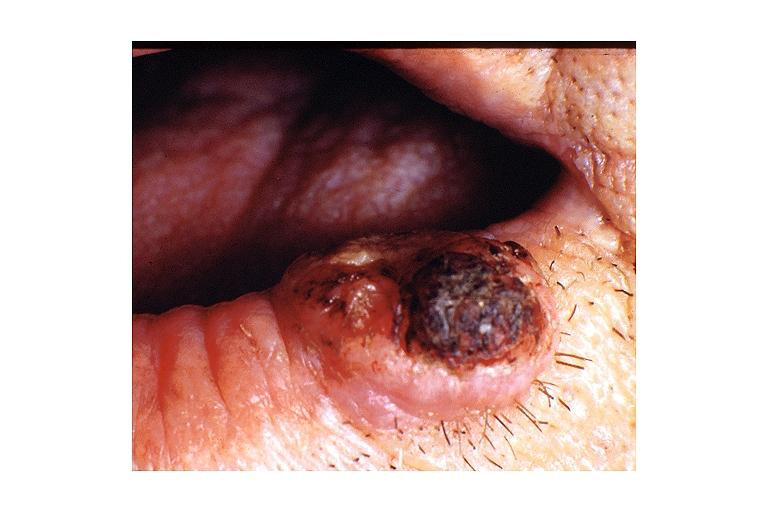does marked show keratoacanthoma?
Answer the question using a single word or phrase. No 